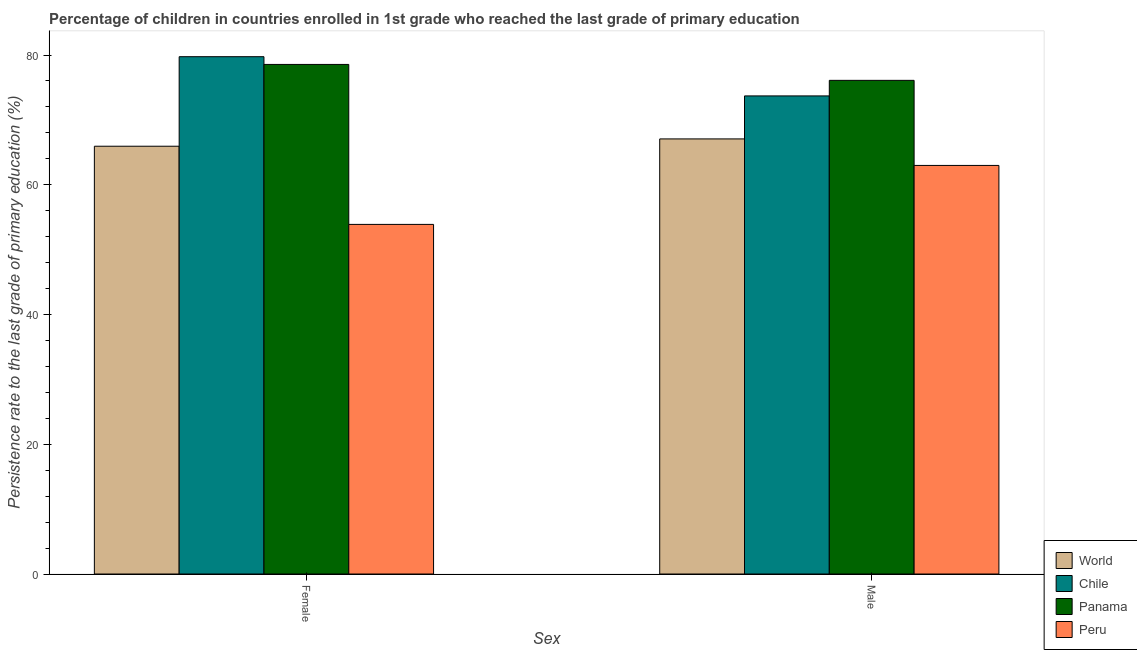How many different coloured bars are there?
Give a very brief answer. 4. How many groups of bars are there?
Your answer should be very brief. 2. Are the number of bars per tick equal to the number of legend labels?
Provide a succinct answer. Yes. How many bars are there on the 1st tick from the left?
Give a very brief answer. 4. How many bars are there on the 2nd tick from the right?
Your answer should be compact. 4. What is the persistence rate of male students in Panama?
Offer a very short reply. 76.1. Across all countries, what is the maximum persistence rate of female students?
Make the answer very short. 79.75. Across all countries, what is the minimum persistence rate of female students?
Your response must be concise. 53.89. In which country was the persistence rate of male students maximum?
Provide a short and direct response. Panama. In which country was the persistence rate of female students minimum?
Your answer should be very brief. Peru. What is the total persistence rate of male students in the graph?
Your answer should be very brief. 279.86. What is the difference between the persistence rate of female students in World and that in Chile?
Keep it short and to the point. -13.8. What is the difference between the persistence rate of male students in Peru and the persistence rate of female students in Panama?
Offer a terse response. -15.57. What is the average persistence rate of male students per country?
Your answer should be compact. 69.96. What is the difference between the persistence rate of female students and persistence rate of male students in Chile?
Your answer should be very brief. 6.05. What is the ratio of the persistence rate of female students in Peru to that in Chile?
Give a very brief answer. 0.68. Is the persistence rate of female students in Peru less than that in Panama?
Offer a terse response. Yes. In how many countries, is the persistence rate of male students greater than the average persistence rate of male students taken over all countries?
Your answer should be very brief. 2. How many bars are there?
Your answer should be very brief. 8. Are all the bars in the graph horizontal?
Give a very brief answer. No. Are the values on the major ticks of Y-axis written in scientific E-notation?
Your response must be concise. No. What is the title of the graph?
Provide a short and direct response. Percentage of children in countries enrolled in 1st grade who reached the last grade of primary education. Does "Sierra Leone" appear as one of the legend labels in the graph?
Keep it short and to the point. No. What is the label or title of the X-axis?
Your answer should be very brief. Sex. What is the label or title of the Y-axis?
Give a very brief answer. Persistence rate to the last grade of primary education (%). What is the Persistence rate to the last grade of primary education (%) in World in Female?
Provide a succinct answer. 65.94. What is the Persistence rate to the last grade of primary education (%) of Chile in Female?
Provide a short and direct response. 79.75. What is the Persistence rate to the last grade of primary education (%) in Panama in Female?
Provide a succinct answer. 78.55. What is the Persistence rate to the last grade of primary education (%) in Peru in Female?
Provide a short and direct response. 53.89. What is the Persistence rate to the last grade of primary education (%) in World in Male?
Provide a succinct answer. 67.07. What is the Persistence rate to the last grade of primary education (%) in Chile in Male?
Your answer should be compact. 73.7. What is the Persistence rate to the last grade of primary education (%) of Panama in Male?
Provide a succinct answer. 76.1. What is the Persistence rate to the last grade of primary education (%) of Peru in Male?
Keep it short and to the point. 62.98. Across all Sex, what is the maximum Persistence rate to the last grade of primary education (%) in World?
Offer a very short reply. 67.07. Across all Sex, what is the maximum Persistence rate to the last grade of primary education (%) of Chile?
Keep it short and to the point. 79.75. Across all Sex, what is the maximum Persistence rate to the last grade of primary education (%) in Panama?
Ensure brevity in your answer.  78.55. Across all Sex, what is the maximum Persistence rate to the last grade of primary education (%) in Peru?
Ensure brevity in your answer.  62.98. Across all Sex, what is the minimum Persistence rate to the last grade of primary education (%) in World?
Your response must be concise. 65.94. Across all Sex, what is the minimum Persistence rate to the last grade of primary education (%) of Chile?
Keep it short and to the point. 73.7. Across all Sex, what is the minimum Persistence rate to the last grade of primary education (%) of Panama?
Make the answer very short. 76.1. Across all Sex, what is the minimum Persistence rate to the last grade of primary education (%) of Peru?
Your answer should be very brief. 53.89. What is the total Persistence rate to the last grade of primary education (%) of World in the graph?
Give a very brief answer. 133.02. What is the total Persistence rate to the last grade of primary education (%) of Chile in the graph?
Keep it short and to the point. 153.45. What is the total Persistence rate to the last grade of primary education (%) in Panama in the graph?
Your answer should be compact. 154.65. What is the total Persistence rate to the last grade of primary education (%) in Peru in the graph?
Offer a very short reply. 116.88. What is the difference between the Persistence rate to the last grade of primary education (%) of World in Female and that in Male?
Offer a terse response. -1.13. What is the difference between the Persistence rate to the last grade of primary education (%) in Chile in Female and that in Male?
Give a very brief answer. 6.05. What is the difference between the Persistence rate to the last grade of primary education (%) in Panama in Female and that in Male?
Keep it short and to the point. 2.45. What is the difference between the Persistence rate to the last grade of primary education (%) of Peru in Female and that in Male?
Make the answer very short. -9.09. What is the difference between the Persistence rate to the last grade of primary education (%) of World in Female and the Persistence rate to the last grade of primary education (%) of Chile in Male?
Make the answer very short. -7.76. What is the difference between the Persistence rate to the last grade of primary education (%) of World in Female and the Persistence rate to the last grade of primary education (%) of Panama in Male?
Your answer should be very brief. -10.16. What is the difference between the Persistence rate to the last grade of primary education (%) of World in Female and the Persistence rate to the last grade of primary education (%) of Peru in Male?
Provide a succinct answer. 2.96. What is the difference between the Persistence rate to the last grade of primary education (%) of Chile in Female and the Persistence rate to the last grade of primary education (%) of Panama in Male?
Offer a terse response. 3.65. What is the difference between the Persistence rate to the last grade of primary education (%) in Chile in Female and the Persistence rate to the last grade of primary education (%) in Peru in Male?
Make the answer very short. 16.76. What is the difference between the Persistence rate to the last grade of primary education (%) of Panama in Female and the Persistence rate to the last grade of primary education (%) of Peru in Male?
Provide a succinct answer. 15.57. What is the average Persistence rate to the last grade of primary education (%) of World per Sex?
Keep it short and to the point. 66.51. What is the average Persistence rate to the last grade of primary education (%) in Chile per Sex?
Provide a short and direct response. 76.72. What is the average Persistence rate to the last grade of primary education (%) in Panama per Sex?
Keep it short and to the point. 77.33. What is the average Persistence rate to the last grade of primary education (%) of Peru per Sex?
Provide a succinct answer. 58.44. What is the difference between the Persistence rate to the last grade of primary education (%) in World and Persistence rate to the last grade of primary education (%) in Chile in Female?
Offer a very short reply. -13.8. What is the difference between the Persistence rate to the last grade of primary education (%) of World and Persistence rate to the last grade of primary education (%) of Panama in Female?
Offer a terse response. -12.61. What is the difference between the Persistence rate to the last grade of primary education (%) in World and Persistence rate to the last grade of primary education (%) in Peru in Female?
Keep it short and to the point. 12.05. What is the difference between the Persistence rate to the last grade of primary education (%) of Chile and Persistence rate to the last grade of primary education (%) of Panama in Female?
Your response must be concise. 1.19. What is the difference between the Persistence rate to the last grade of primary education (%) in Chile and Persistence rate to the last grade of primary education (%) in Peru in Female?
Ensure brevity in your answer.  25.85. What is the difference between the Persistence rate to the last grade of primary education (%) in Panama and Persistence rate to the last grade of primary education (%) in Peru in Female?
Offer a terse response. 24.66. What is the difference between the Persistence rate to the last grade of primary education (%) of World and Persistence rate to the last grade of primary education (%) of Chile in Male?
Your answer should be very brief. -6.63. What is the difference between the Persistence rate to the last grade of primary education (%) in World and Persistence rate to the last grade of primary education (%) in Panama in Male?
Offer a terse response. -9.03. What is the difference between the Persistence rate to the last grade of primary education (%) of World and Persistence rate to the last grade of primary education (%) of Peru in Male?
Make the answer very short. 4.09. What is the difference between the Persistence rate to the last grade of primary education (%) of Chile and Persistence rate to the last grade of primary education (%) of Panama in Male?
Provide a succinct answer. -2.4. What is the difference between the Persistence rate to the last grade of primary education (%) of Chile and Persistence rate to the last grade of primary education (%) of Peru in Male?
Your answer should be very brief. 10.72. What is the difference between the Persistence rate to the last grade of primary education (%) of Panama and Persistence rate to the last grade of primary education (%) of Peru in Male?
Ensure brevity in your answer.  13.12. What is the ratio of the Persistence rate to the last grade of primary education (%) of World in Female to that in Male?
Ensure brevity in your answer.  0.98. What is the ratio of the Persistence rate to the last grade of primary education (%) in Chile in Female to that in Male?
Your response must be concise. 1.08. What is the ratio of the Persistence rate to the last grade of primary education (%) of Panama in Female to that in Male?
Make the answer very short. 1.03. What is the ratio of the Persistence rate to the last grade of primary education (%) in Peru in Female to that in Male?
Your answer should be compact. 0.86. What is the difference between the highest and the second highest Persistence rate to the last grade of primary education (%) of World?
Your response must be concise. 1.13. What is the difference between the highest and the second highest Persistence rate to the last grade of primary education (%) of Chile?
Make the answer very short. 6.05. What is the difference between the highest and the second highest Persistence rate to the last grade of primary education (%) in Panama?
Offer a very short reply. 2.45. What is the difference between the highest and the second highest Persistence rate to the last grade of primary education (%) of Peru?
Offer a very short reply. 9.09. What is the difference between the highest and the lowest Persistence rate to the last grade of primary education (%) of World?
Provide a succinct answer. 1.13. What is the difference between the highest and the lowest Persistence rate to the last grade of primary education (%) of Chile?
Your response must be concise. 6.05. What is the difference between the highest and the lowest Persistence rate to the last grade of primary education (%) in Panama?
Make the answer very short. 2.45. What is the difference between the highest and the lowest Persistence rate to the last grade of primary education (%) in Peru?
Your answer should be compact. 9.09. 